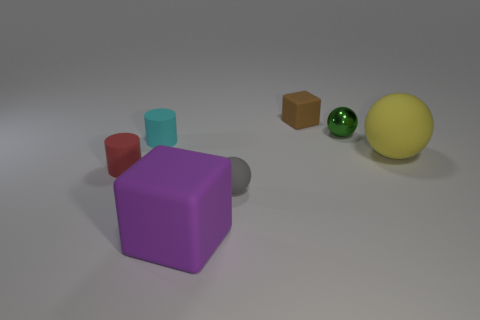Subtract all small matte spheres. How many spheres are left? 2 Subtract all spheres. How many objects are left? 4 Add 3 tiny cyan cylinders. How many objects exist? 10 Subtract all brown blocks. How many blocks are left? 1 Subtract 1 cylinders. How many cylinders are left? 1 Subtract all gray balls. How many cyan cylinders are left? 1 Add 7 purple blocks. How many purple blocks are left? 8 Add 6 red matte objects. How many red matte objects exist? 7 Subtract 1 green spheres. How many objects are left? 6 Subtract all brown balls. Subtract all green cylinders. How many balls are left? 3 